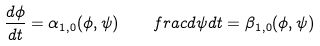Convert formula to latex. <formula><loc_0><loc_0><loc_500><loc_500>\frac { d \phi } { d t } = \alpha _ { 1 , 0 } ( \phi , \psi ) \quad f r a c { d \psi } { d t } = \beta _ { 1 , 0 } ( \phi , \psi )</formula> 